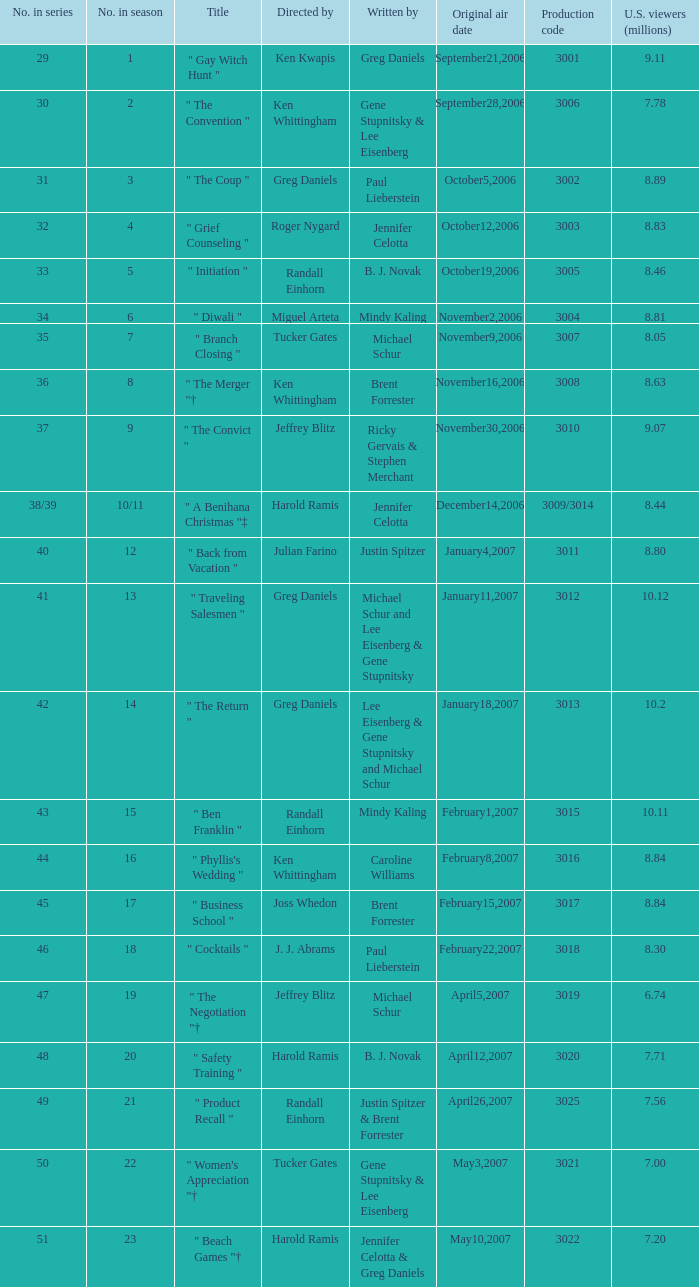Name the number of original air date for when the number in season is 10/11 1.0. 